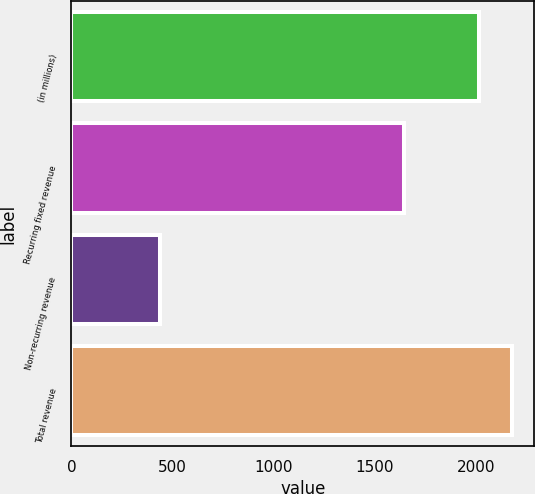Convert chart. <chart><loc_0><loc_0><loc_500><loc_500><bar_chart><fcel>(in millions)<fcel>Recurring fixed revenue<fcel>Non-recurring revenue<fcel>Total revenue<nl><fcel>2014<fcel>1643.9<fcel>435.9<fcel>2178.39<nl></chart> 